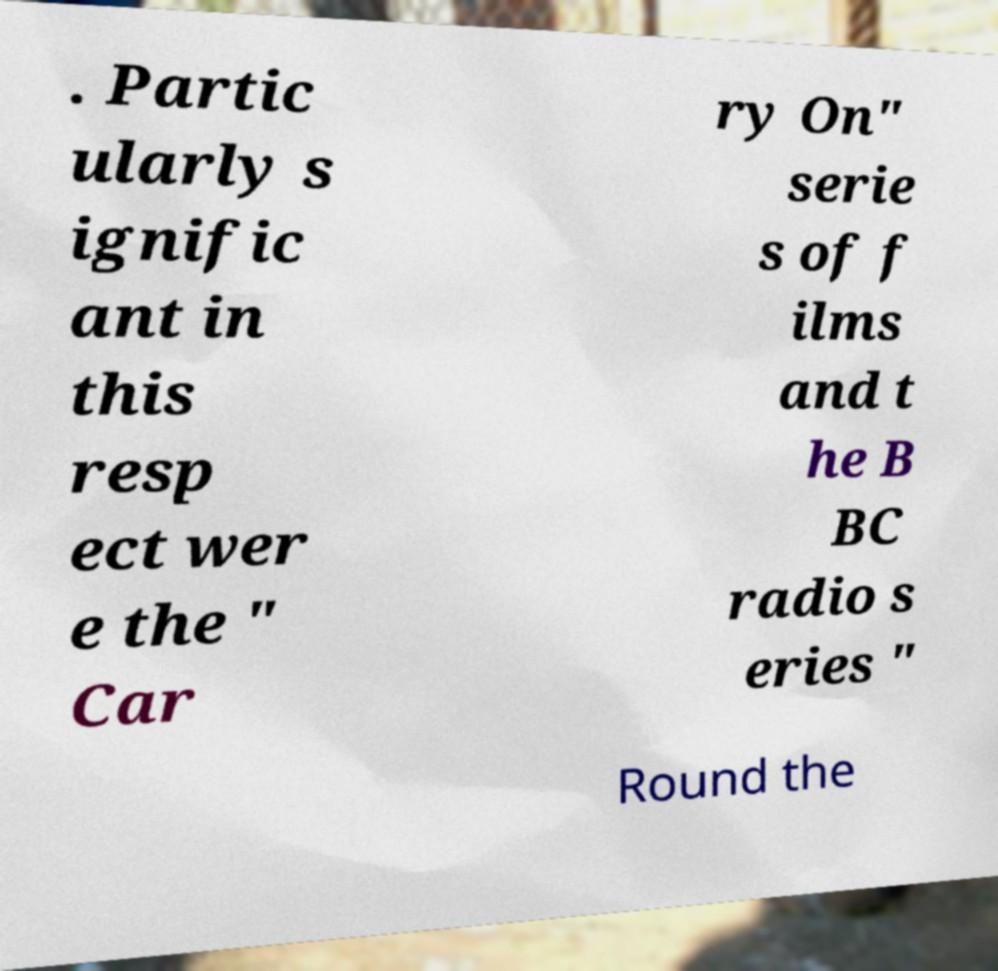For documentation purposes, I need the text within this image transcribed. Could you provide that? . Partic ularly s ignific ant in this resp ect wer e the " Car ry On" serie s of f ilms and t he B BC radio s eries " Round the 